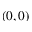<formula> <loc_0><loc_0><loc_500><loc_500>( 0 , 0 )</formula> 